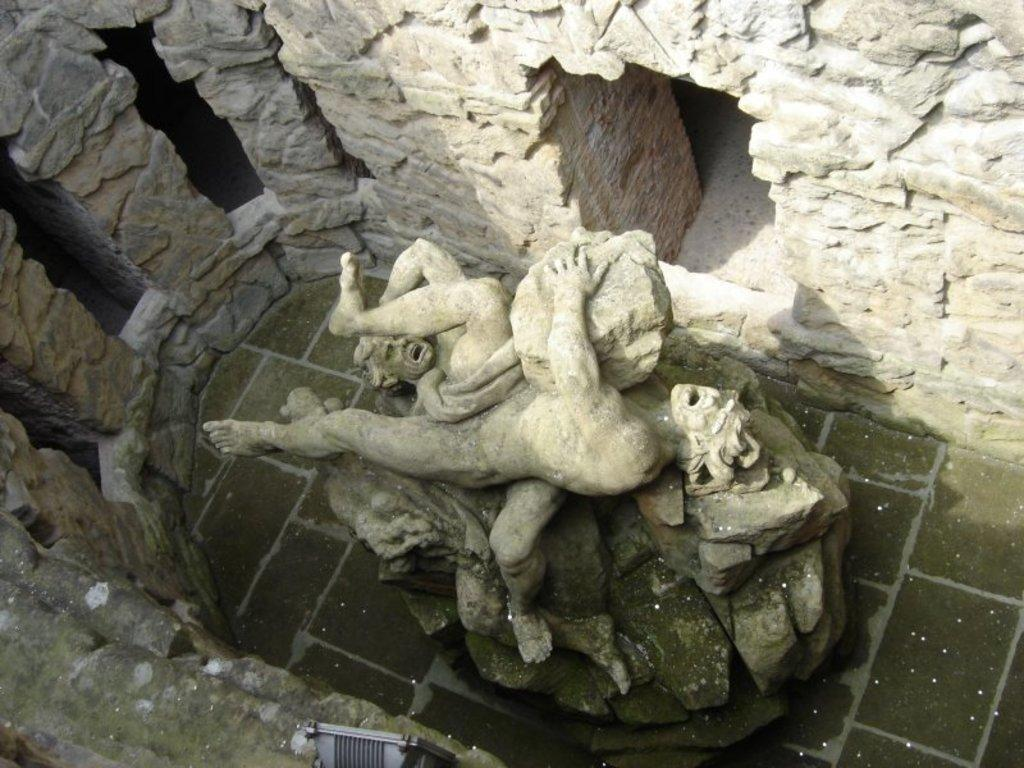What is the main subject of the image? The main subject of the image is a statue of two persons. What is surrounding the statue? The statue is surrounded by rock walls. Can you describe the color of one of the rocks in the image? There is a rock in the image that is ash in color. What is the color of another object in the image? There is a black colored object in the image. Is there a kite flying over the statue in the image? No, there is no kite present in the image. Can you see the roof of the building behind the statue in the image? There is no building or roof visible in the image; it only features the statue and rock walls. 